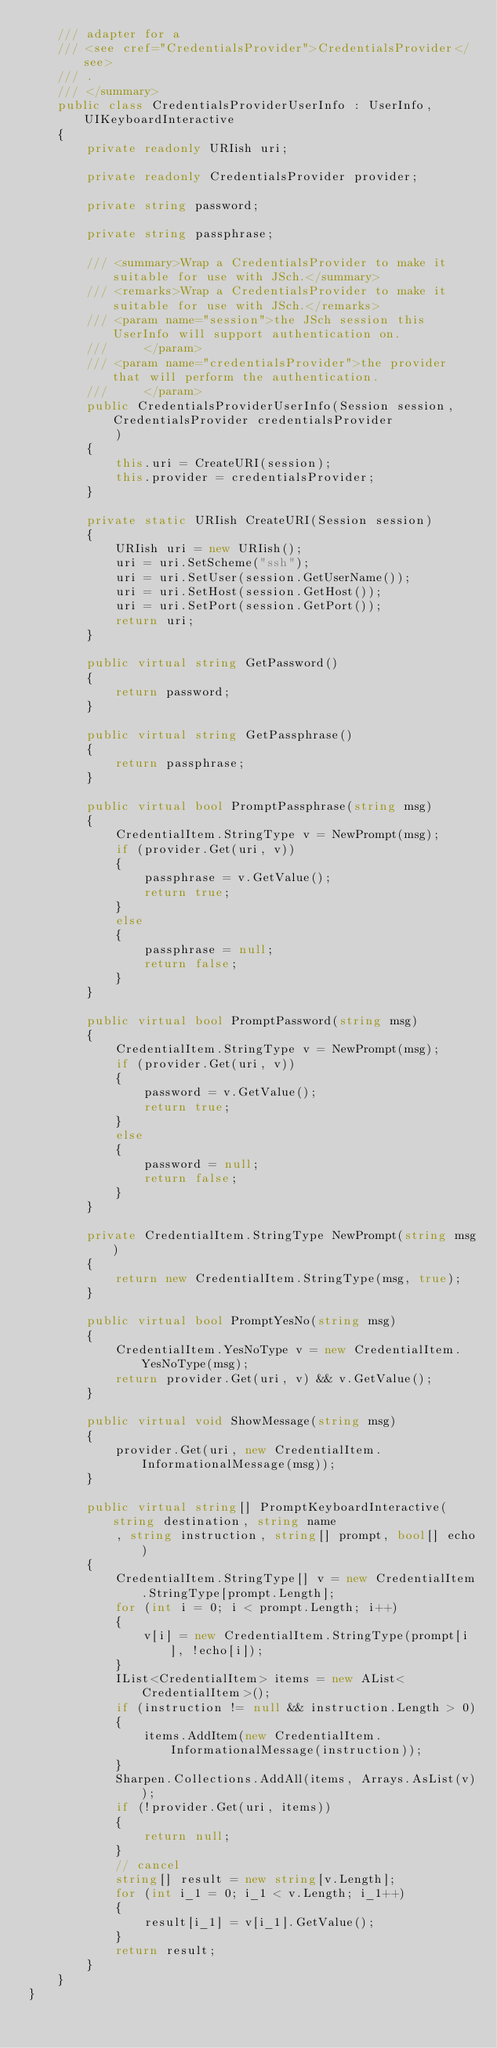<code> <loc_0><loc_0><loc_500><loc_500><_C#_>	/// adapter for a
	/// <see cref="CredentialsProvider">CredentialsProvider</see>
	/// .
	/// </summary>
	public class CredentialsProviderUserInfo : UserInfo, UIKeyboardInteractive
	{
		private readonly URIish uri;

		private readonly CredentialsProvider provider;

		private string password;

		private string passphrase;

		/// <summary>Wrap a CredentialsProvider to make it suitable for use with JSch.</summary>
		/// <remarks>Wrap a CredentialsProvider to make it suitable for use with JSch.</remarks>
		/// <param name="session">the JSch session this UserInfo will support authentication on.
		/// 	</param>
		/// <param name="credentialsProvider">the provider that will perform the authentication.
		/// 	</param>
		public CredentialsProviderUserInfo(Session session, CredentialsProvider credentialsProvider
			)
		{
			this.uri = CreateURI(session);
			this.provider = credentialsProvider;
		}

		private static URIish CreateURI(Session session)
		{
			URIish uri = new URIish();
			uri = uri.SetScheme("ssh");
			uri = uri.SetUser(session.GetUserName());
			uri = uri.SetHost(session.GetHost());
			uri = uri.SetPort(session.GetPort());
			return uri;
		}

		public virtual string GetPassword()
		{
			return password;
		}

		public virtual string GetPassphrase()
		{
			return passphrase;
		}

		public virtual bool PromptPassphrase(string msg)
		{
			CredentialItem.StringType v = NewPrompt(msg);
			if (provider.Get(uri, v))
			{
				passphrase = v.GetValue();
				return true;
			}
			else
			{
				passphrase = null;
				return false;
			}
		}

		public virtual bool PromptPassword(string msg)
		{
			CredentialItem.StringType v = NewPrompt(msg);
			if (provider.Get(uri, v))
			{
				password = v.GetValue();
				return true;
			}
			else
			{
				password = null;
				return false;
			}
		}

		private CredentialItem.StringType NewPrompt(string msg)
		{
			return new CredentialItem.StringType(msg, true);
		}

		public virtual bool PromptYesNo(string msg)
		{
			CredentialItem.YesNoType v = new CredentialItem.YesNoType(msg);
			return provider.Get(uri, v) && v.GetValue();
		}

		public virtual void ShowMessage(string msg)
		{
			provider.Get(uri, new CredentialItem.InformationalMessage(msg));
		}

		public virtual string[] PromptKeyboardInteractive(string destination, string name
			, string instruction, string[] prompt, bool[] echo)
		{
			CredentialItem.StringType[] v = new CredentialItem.StringType[prompt.Length];
			for (int i = 0; i < prompt.Length; i++)
			{
				v[i] = new CredentialItem.StringType(prompt[i], !echo[i]);
			}
			IList<CredentialItem> items = new AList<CredentialItem>();
			if (instruction != null && instruction.Length > 0)
			{
				items.AddItem(new CredentialItem.InformationalMessage(instruction));
			}
			Sharpen.Collections.AddAll(items, Arrays.AsList(v));
			if (!provider.Get(uri, items))
			{
				return null;
			}
			// cancel
			string[] result = new string[v.Length];
			for (int i_1 = 0; i_1 < v.Length; i_1++)
			{
				result[i_1] = v[i_1].GetValue();
			}
			return result;
		}
	}
}
</code> 